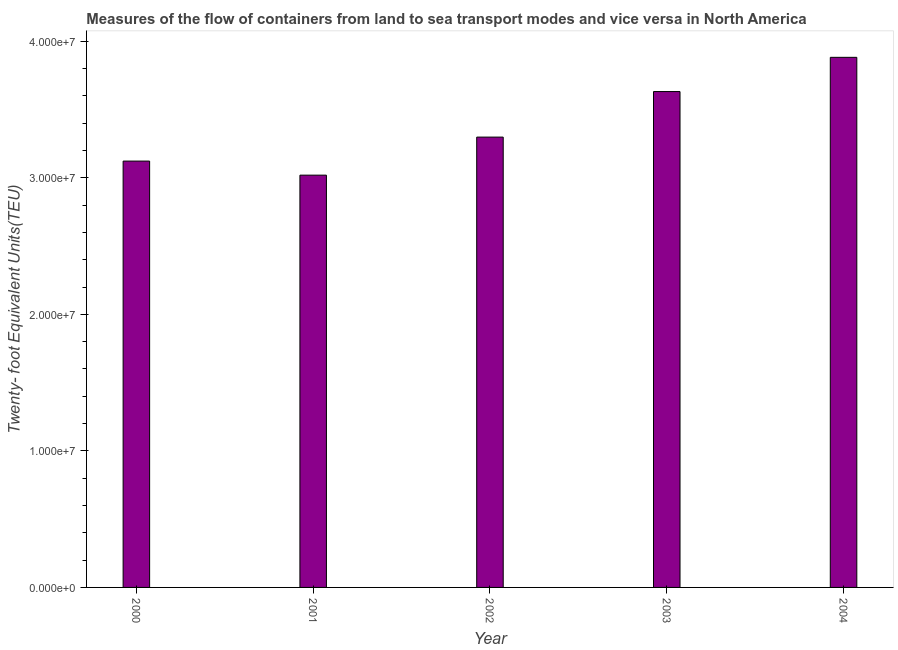What is the title of the graph?
Provide a short and direct response. Measures of the flow of containers from land to sea transport modes and vice versa in North America. What is the label or title of the Y-axis?
Your answer should be very brief. Twenty- foot Equivalent Units(TEU). What is the container port traffic in 2004?
Your answer should be very brief. 3.88e+07. Across all years, what is the maximum container port traffic?
Provide a succinct answer. 3.88e+07. Across all years, what is the minimum container port traffic?
Your answer should be very brief. 3.02e+07. In which year was the container port traffic maximum?
Offer a very short reply. 2004. What is the sum of the container port traffic?
Offer a very short reply. 1.70e+08. What is the difference between the container port traffic in 2002 and 2004?
Offer a very short reply. -5.84e+06. What is the average container port traffic per year?
Offer a terse response. 3.39e+07. What is the median container port traffic?
Offer a very short reply. 3.30e+07. Do a majority of the years between 2003 and 2000 (inclusive) have container port traffic greater than 28000000 TEU?
Keep it short and to the point. Yes. What is the ratio of the container port traffic in 2003 to that in 2004?
Offer a terse response. 0.94. Is the container port traffic in 2000 less than that in 2003?
Provide a short and direct response. Yes. What is the difference between the highest and the second highest container port traffic?
Ensure brevity in your answer.  2.51e+06. Is the sum of the container port traffic in 2001 and 2003 greater than the maximum container port traffic across all years?
Provide a short and direct response. Yes. What is the difference between the highest and the lowest container port traffic?
Ensure brevity in your answer.  8.63e+06. How many bars are there?
Make the answer very short. 5. How many years are there in the graph?
Make the answer very short. 5. What is the difference between two consecutive major ticks on the Y-axis?
Ensure brevity in your answer.  1.00e+07. What is the Twenty- foot Equivalent Units(TEU) in 2000?
Provide a short and direct response. 3.12e+07. What is the Twenty- foot Equivalent Units(TEU) of 2001?
Give a very brief answer. 3.02e+07. What is the Twenty- foot Equivalent Units(TEU) in 2002?
Make the answer very short. 3.30e+07. What is the Twenty- foot Equivalent Units(TEU) in 2003?
Give a very brief answer. 3.63e+07. What is the Twenty- foot Equivalent Units(TEU) of 2004?
Your response must be concise. 3.88e+07. What is the difference between the Twenty- foot Equivalent Units(TEU) in 2000 and 2001?
Keep it short and to the point. 1.03e+06. What is the difference between the Twenty- foot Equivalent Units(TEU) in 2000 and 2002?
Your answer should be very brief. -1.76e+06. What is the difference between the Twenty- foot Equivalent Units(TEU) in 2000 and 2003?
Your response must be concise. -5.09e+06. What is the difference between the Twenty- foot Equivalent Units(TEU) in 2000 and 2004?
Provide a succinct answer. -7.60e+06. What is the difference between the Twenty- foot Equivalent Units(TEU) in 2001 and 2002?
Provide a short and direct response. -2.79e+06. What is the difference between the Twenty- foot Equivalent Units(TEU) in 2001 and 2003?
Make the answer very short. -6.12e+06. What is the difference between the Twenty- foot Equivalent Units(TEU) in 2001 and 2004?
Provide a short and direct response. -8.63e+06. What is the difference between the Twenty- foot Equivalent Units(TEU) in 2002 and 2003?
Provide a short and direct response. -3.34e+06. What is the difference between the Twenty- foot Equivalent Units(TEU) in 2002 and 2004?
Your answer should be compact. -5.84e+06. What is the difference between the Twenty- foot Equivalent Units(TEU) in 2003 and 2004?
Your answer should be very brief. -2.51e+06. What is the ratio of the Twenty- foot Equivalent Units(TEU) in 2000 to that in 2001?
Make the answer very short. 1.03. What is the ratio of the Twenty- foot Equivalent Units(TEU) in 2000 to that in 2002?
Keep it short and to the point. 0.95. What is the ratio of the Twenty- foot Equivalent Units(TEU) in 2000 to that in 2003?
Provide a short and direct response. 0.86. What is the ratio of the Twenty- foot Equivalent Units(TEU) in 2000 to that in 2004?
Ensure brevity in your answer.  0.8. What is the ratio of the Twenty- foot Equivalent Units(TEU) in 2001 to that in 2002?
Make the answer very short. 0.92. What is the ratio of the Twenty- foot Equivalent Units(TEU) in 2001 to that in 2003?
Your answer should be compact. 0.83. What is the ratio of the Twenty- foot Equivalent Units(TEU) in 2001 to that in 2004?
Offer a very short reply. 0.78. What is the ratio of the Twenty- foot Equivalent Units(TEU) in 2002 to that in 2003?
Your response must be concise. 0.91. What is the ratio of the Twenty- foot Equivalent Units(TEU) in 2002 to that in 2004?
Your answer should be compact. 0.85. What is the ratio of the Twenty- foot Equivalent Units(TEU) in 2003 to that in 2004?
Provide a succinct answer. 0.94. 